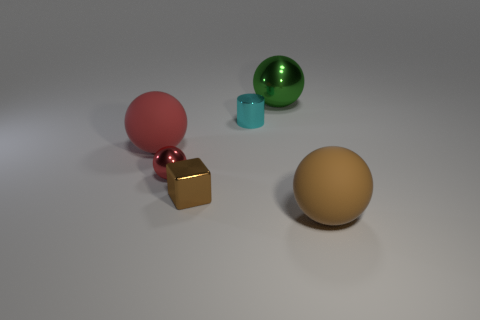There is a large red thing that is the same shape as the small red thing; what is it made of?
Your answer should be compact. Rubber. There is a metallic ball in front of the large thing that is behind the small cyan object; how big is it?
Ensure brevity in your answer.  Small. There is a small object that is in front of the small sphere; what is it made of?
Ensure brevity in your answer.  Metal. There is a green object that is made of the same material as the cyan cylinder; what is its size?
Offer a terse response. Large. What number of small red shiny things have the same shape as the brown rubber object?
Offer a terse response. 1. There is a small cyan metal object; is its shape the same as the rubber thing behind the large brown sphere?
Provide a succinct answer. No. The matte thing that is the same color as the cube is what shape?
Your response must be concise. Sphere. Is there a thing that has the same material as the brown sphere?
Your answer should be compact. Yes. What is the material of the brown thing to the right of the tiny metallic thing that is behind the red rubber object?
Offer a very short reply. Rubber. There is a metal object that is in front of the metallic ball to the left of the brown thing that is left of the cyan thing; what size is it?
Provide a short and direct response. Small. 